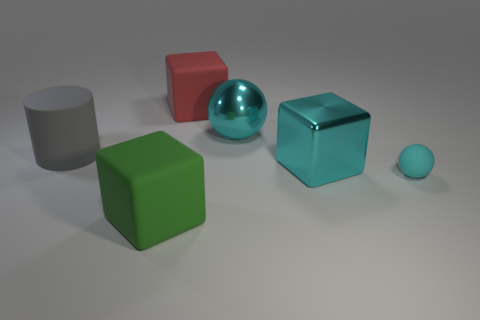How many green objects are tiny objects or cylinders?
Offer a very short reply. 0. What number of large red blocks are left of the large cyan metallic cube?
Your response must be concise. 1. Are there more small cyan shiny cubes than large cyan blocks?
Your answer should be compact. No. What is the shape of the metallic object on the right side of the ball on the left side of the small rubber ball?
Offer a terse response. Cube. Is the small rubber ball the same color as the big matte cylinder?
Ensure brevity in your answer.  No. Is the number of metallic things behind the red rubber block greater than the number of yellow spheres?
Provide a short and direct response. No. What number of large green rubber blocks are on the right side of the rubber block left of the large red cube?
Ensure brevity in your answer.  0. Does the object that is behind the large cyan sphere have the same material as the object on the left side of the big green matte block?
Keep it short and to the point. Yes. What material is the tiny object that is the same color as the metallic sphere?
Offer a terse response. Rubber. How many other green rubber objects are the same shape as the small object?
Provide a short and direct response. 0. 